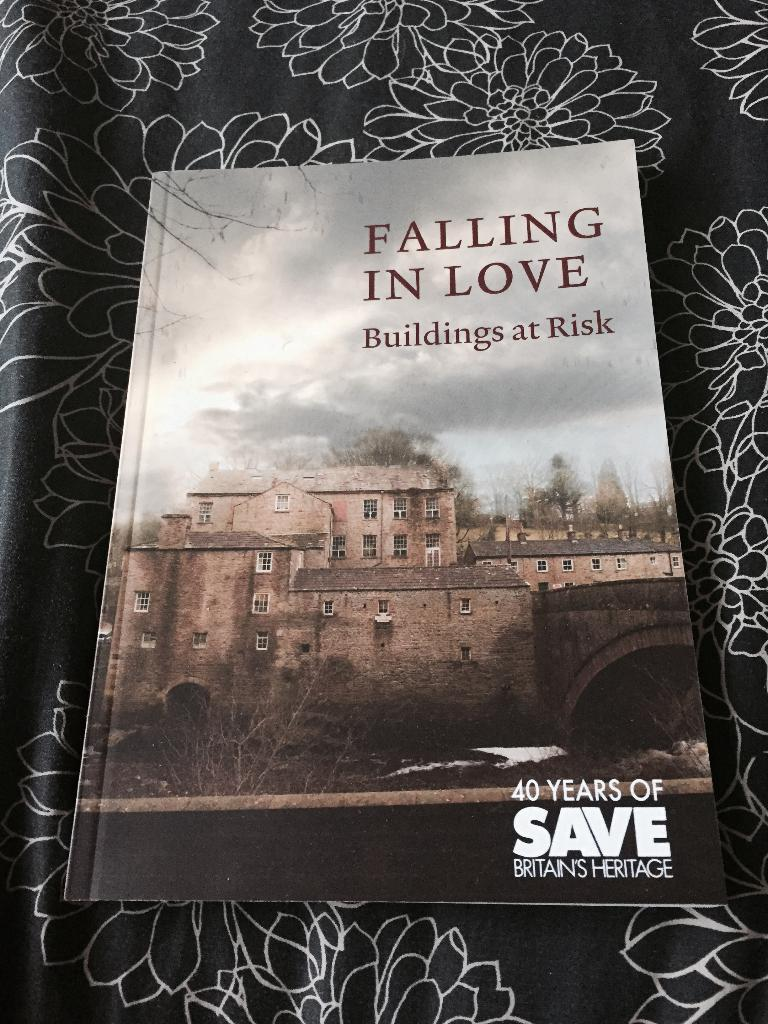<image>
Create a compact narrative representing the image presented. Book about Britain's Heritage titled Falling in Love, Buildings at Risk. 